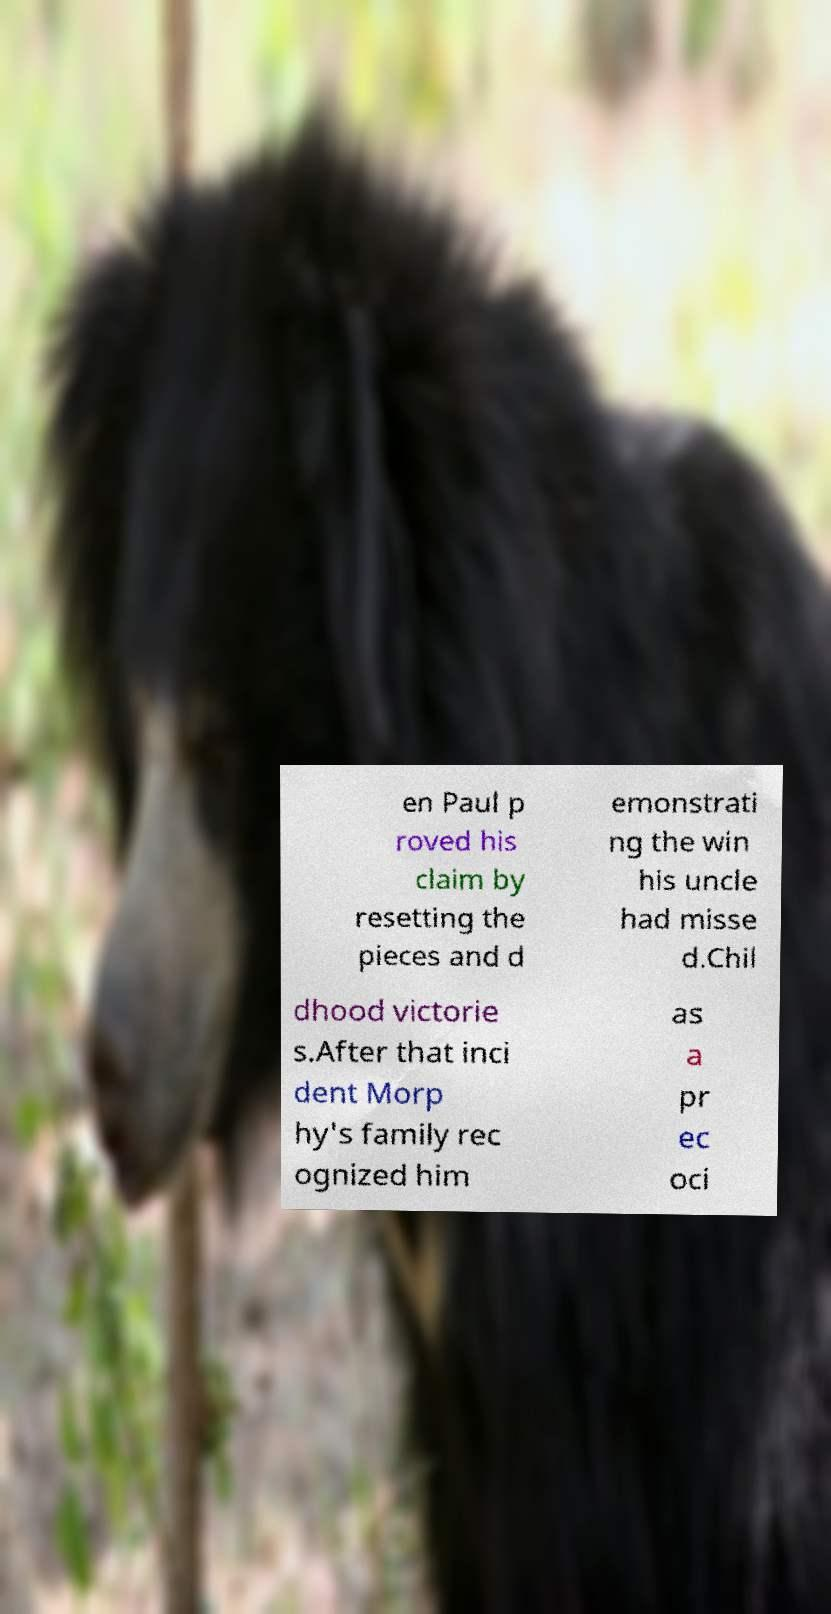Can you accurately transcribe the text from the provided image for me? en Paul p roved his claim by resetting the pieces and d emonstrati ng the win his uncle had misse d.Chil dhood victorie s.After that inci dent Morp hy's family rec ognized him as a pr ec oci 